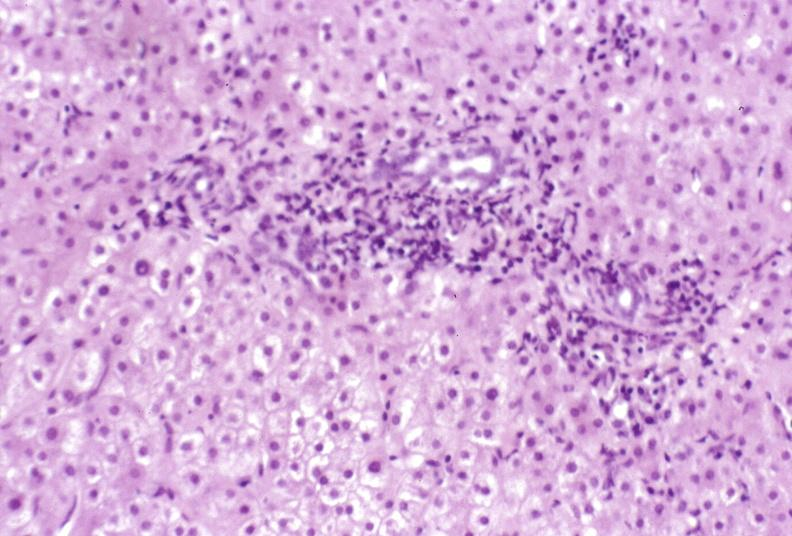what does this image show?
Answer the question using a single word or phrase. Primary biliary cirrhosis 